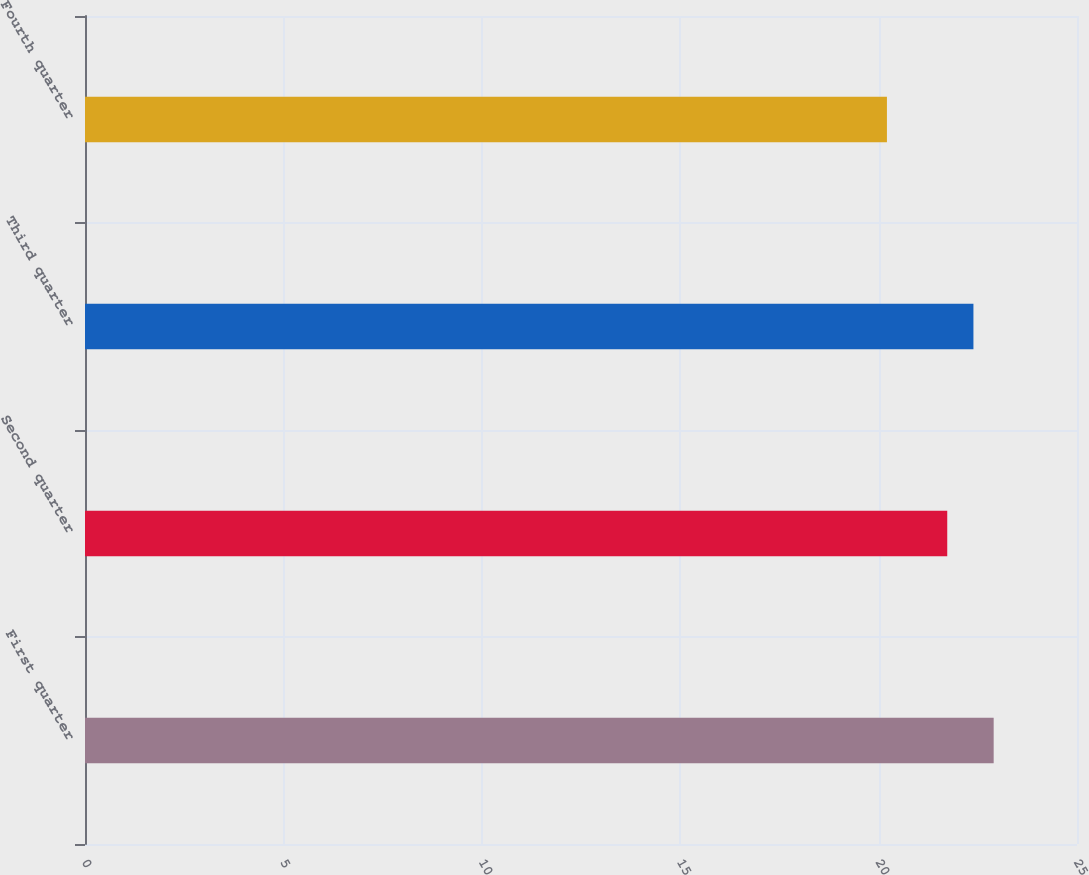<chart> <loc_0><loc_0><loc_500><loc_500><bar_chart><fcel>First quarter<fcel>Second quarter<fcel>Third quarter<fcel>Fourth quarter<nl><fcel>22.9<fcel>21.73<fcel>22.39<fcel>20.21<nl></chart> 